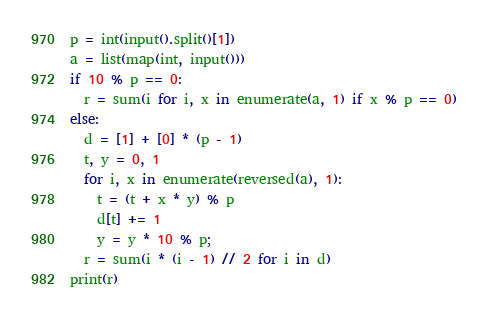Convert code to text. <code><loc_0><loc_0><loc_500><loc_500><_Python_>p = int(input().split()[1])
a = list(map(int, input()))
if 10 % p == 0:
  r = sum(i for i, x in enumerate(a, 1) if x % p == 0)
else:
  d = [1] + [0] * (p - 1)
  t, y = 0, 1
  for i, x in enumerate(reversed(a), 1):
    t = (t + x * y) % p
    d[t] += 1
    y = y * 10 % p;
  r = sum(i * (i - 1) // 2 for i in d)
print(r)
</code> 